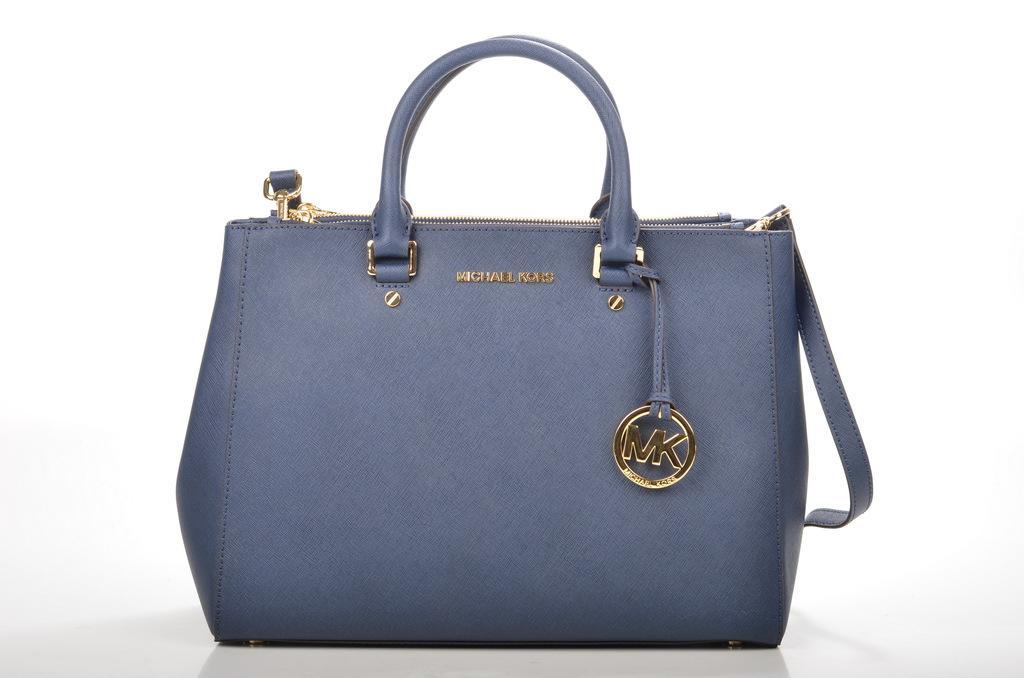Could you give a brief overview of what you see in this image? There is a beautiful hand bag in the middle of the picture ,there is a text written on that bag. 